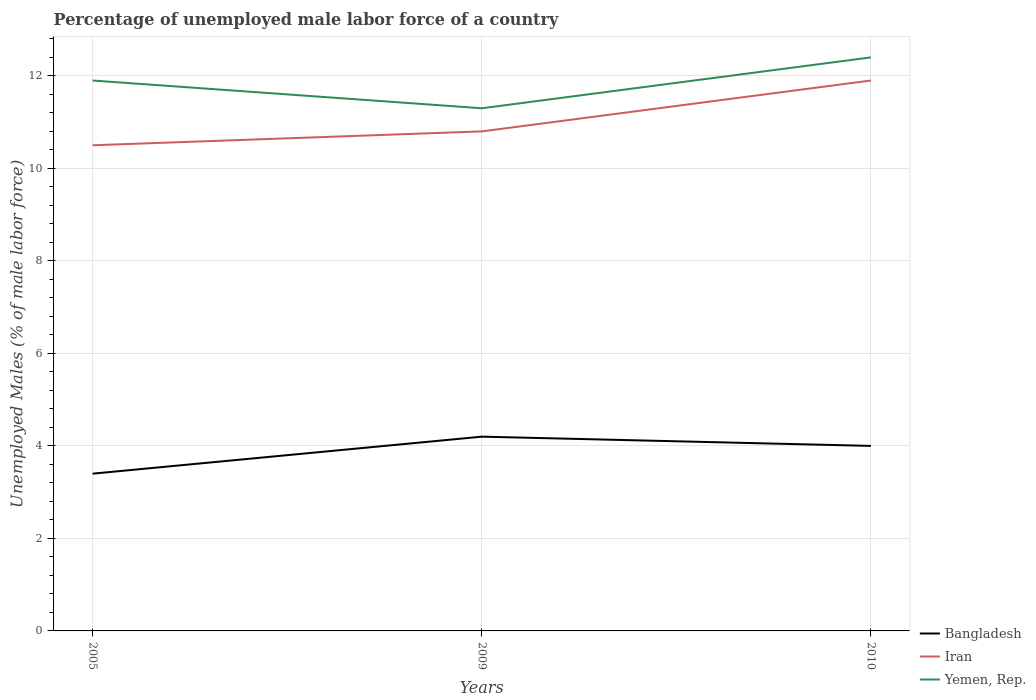Does the line corresponding to Yemen, Rep. intersect with the line corresponding to Bangladesh?
Offer a very short reply. No. Is the number of lines equal to the number of legend labels?
Keep it short and to the point. Yes. Across all years, what is the maximum percentage of unemployed male labor force in Yemen, Rep.?
Your answer should be compact. 11.3. What is the total percentage of unemployed male labor force in Iran in the graph?
Your answer should be very brief. -1.1. What is the difference between the highest and the second highest percentage of unemployed male labor force in Yemen, Rep.?
Provide a succinct answer. 1.1. What is the difference between the highest and the lowest percentage of unemployed male labor force in Iran?
Offer a very short reply. 1. Is the percentage of unemployed male labor force in Bangladesh strictly greater than the percentage of unemployed male labor force in Iran over the years?
Your response must be concise. Yes. How many lines are there?
Provide a succinct answer. 3. Are the values on the major ticks of Y-axis written in scientific E-notation?
Offer a very short reply. No. Does the graph contain grids?
Your answer should be compact. Yes. How many legend labels are there?
Give a very brief answer. 3. What is the title of the graph?
Provide a succinct answer. Percentage of unemployed male labor force of a country. What is the label or title of the X-axis?
Make the answer very short. Years. What is the label or title of the Y-axis?
Ensure brevity in your answer.  Unemployed Males (% of male labor force). What is the Unemployed Males (% of male labor force) in Bangladesh in 2005?
Offer a very short reply. 3.4. What is the Unemployed Males (% of male labor force) of Yemen, Rep. in 2005?
Your answer should be very brief. 11.9. What is the Unemployed Males (% of male labor force) of Bangladesh in 2009?
Give a very brief answer. 4.2. What is the Unemployed Males (% of male labor force) of Iran in 2009?
Offer a terse response. 10.8. What is the Unemployed Males (% of male labor force) of Yemen, Rep. in 2009?
Keep it short and to the point. 11.3. What is the Unemployed Males (% of male labor force) in Iran in 2010?
Your answer should be very brief. 11.9. What is the Unemployed Males (% of male labor force) in Yemen, Rep. in 2010?
Your response must be concise. 12.4. Across all years, what is the maximum Unemployed Males (% of male labor force) in Bangladesh?
Your answer should be compact. 4.2. Across all years, what is the maximum Unemployed Males (% of male labor force) in Iran?
Your answer should be compact. 11.9. Across all years, what is the maximum Unemployed Males (% of male labor force) of Yemen, Rep.?
Your response must be concise. 12.4. Across all years, what is the minimum Unemployed Males (% of male labor force) of Bangladesh?
Ensure brevity in your answer.  3.4. Across all years, what is the minimum Unemployed Males (% of male labor force) of Yemen, Rep.?
Your answer should be compact. 11.3. What is the total Unemployed Males (% of male labor force) in Iran in the graph?
Provide a short and direct response. 33.2. What is the total Unemployed Males (% of male labor force) of Yemen, Rep. in the graph?
Keep it short and to the point. 35.6. What is the difference between the Unemployed Males (% of male labor force) of Bangladesh in 2005 and that in 2010?
Provide a short and direct response. -0.6. What is the difference between the Unemployed Males (% of male labor force) of Yemen, Rep. in 2009 and that in 2010?
Offer a very short reply. -1.1. What is the difference between the Unemployed Males (% of male labor force) of Bangladesh in 2005 and the Unemployed Males (% of male labor force) of Iran in 2009?
Keep it short and to the point. -7.4. What is the difference between the Unemployed Males (% of male labor force) of Bangladesh in 2005 and the Unemployed Males (% of male labor force) of Yemen, Rep. in 2009?
Provide a succinct answer. -7.9. What is the difference between the Unemployed Males (% of male labor force) of Iran in 2005 and the Unemployed Males (% of male labor force) of Yemen, Rep. in 2010?
Offer a very short reply. -1.9. What is the difference between the Unemployed Males (% of male labor force) in Bangladesh in 2009 and the Unemployed Males (% of male labor force) in Iran in 2010?
Offer a very short reply. -7.7. What is the average Unemployed Males (% of male labor force) in Bangladesh per year?
Provide a succinct answer. 3.87. What is the average Unemployed Males (% of male labor force) in Iran per year?
Your answer should be very brief. 11.07. What is the average Unemployed Males (% of male labor force) of Yemen, Rep. per year?
Keep it short and to the point. 11.87. In the year 2005, what is the difference between the Unemployed Males (% of male labor force) in Bangladesh and Unemployed Males (% of male labor force) in Iran?
Provide a succinct answer. -7.1. In the year 2005, what is the difference between the Unemployed Males (% of male labor force) in Iran and Unemployed Males (% of male labor force) in Yemen, Rep.?
Provide a succinct answer. -1.4. In the year 2009, what is the difference between the Unemployed Males (% of male labor force) of Bangladesh and Unemployed Males (% of male labor force) of Yemen, Rep.?
Offer a terse response. -7.1. In the year 2009, what is the difference between the Unemployed Males (% of male labor force) in Iran and Unemployed Males (% of male labor force) in Yemen, Rep.?
Your response must be concise. -0.5. What is the ratio of the Unemployed Males (% of male labor force) in Bangladesh in 2005 to that in 2009?
Keep it short and to the point. 0.81. What is the ratio of the Unemployed Males (% of male labor force) of Iran in 2005 to that in 2009?
Your response must be concise. 0.97. What is the ratio of the Unemployed Males (% of male labor force) in Yemen, Rep. in 2005 to that in 2009?
Keep it short and to the point. 1.05. What is the ratio of the Unemployed Males (% of male labor force) in Iran in 2005 to that in 2010?
Offer a terse response. 0.88. What is the ratio of the Unemployed Males (% of male labor force) of Yemen, Rep. in 2005 to that in 2010?
Keep it short and to the point. 0.96. What is the ratio of the Unemployed Males (% of male labor force) of Iran in 2009 to that in 2010?
Your answer should be compact. 0.91. What is the ratio of the Unemployed Males (% of male labor force) in Yemen, Rep. in 2009 to that in 2010?
Your answer should be compact. 0.91. What is the difference between the highest and the second highest Unemployed Males (% of male labor force) in Bangladesh?
Provide a succinct answer. 0.2. What is the difference between the highest and the second highest Unemployed Males (% of male labor force) of Iran?
Give a very brief answer. 1.1. What is the difference between the highest and the lowest Unemployed Males (% of male labor force) in Bangladesh?
Your answer should be very brief. 0.8. What is the difference between the highest and the lowest Unemployed Males (% of male labor force) of Yemen, Rep.?
Keep it short and to the point. 1.1. 